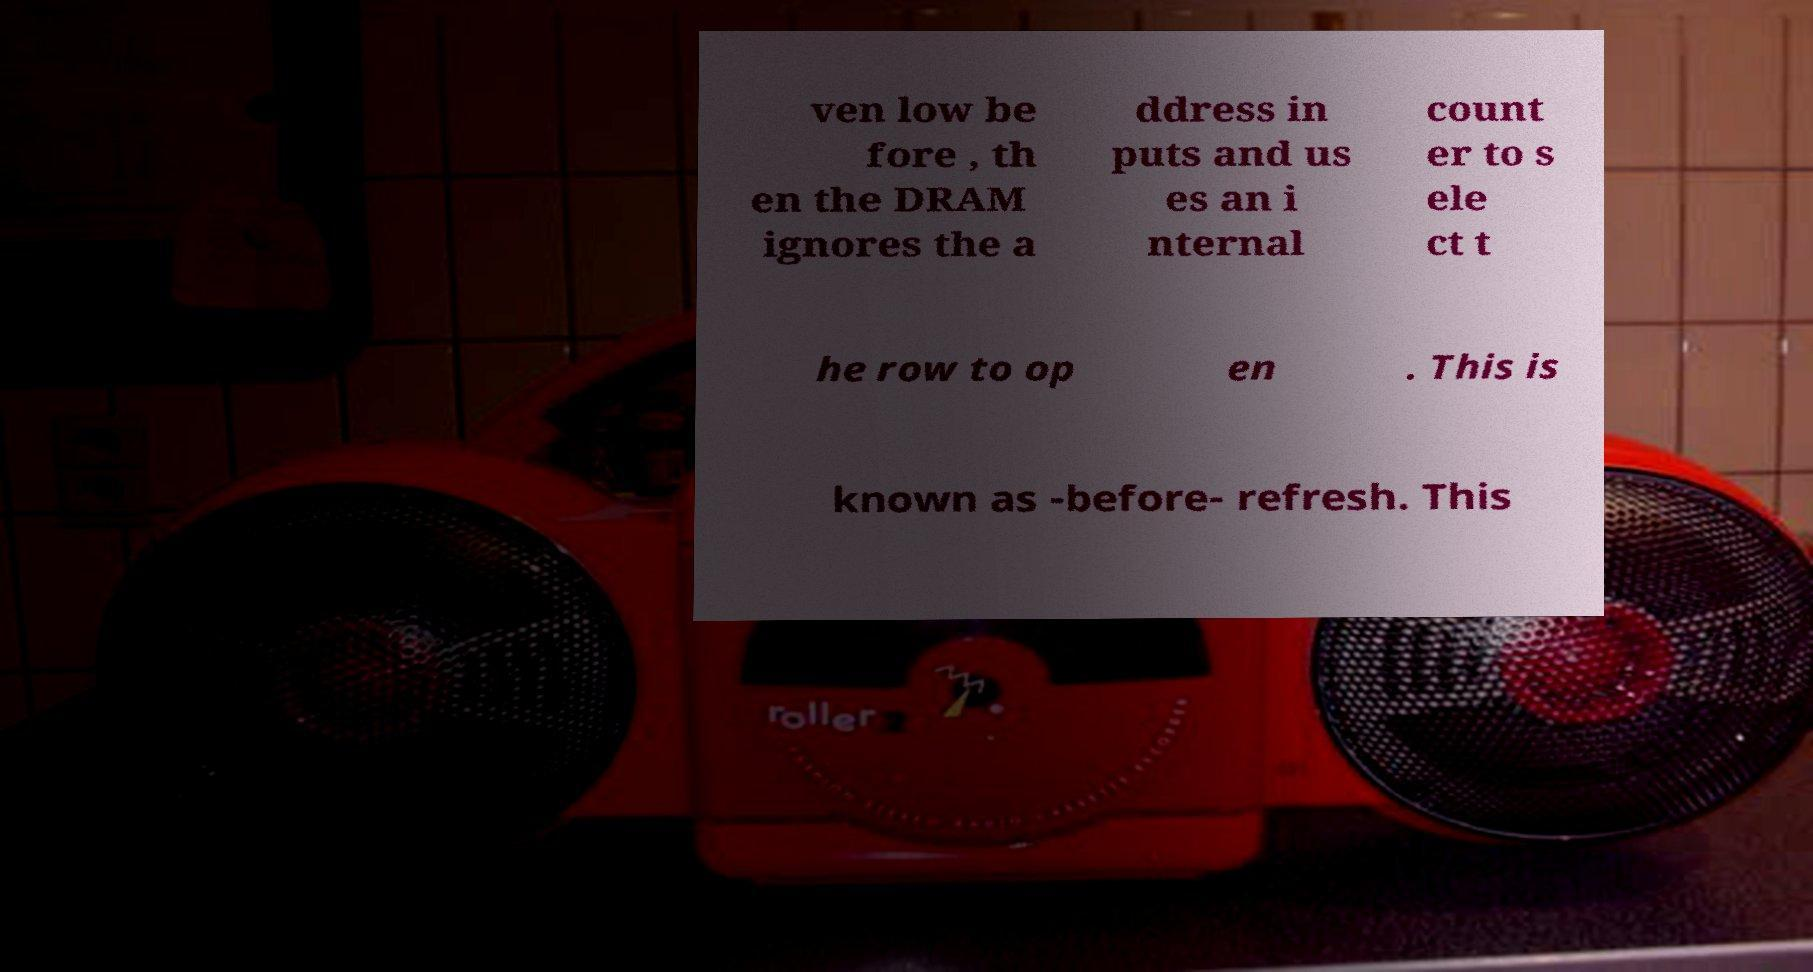What messages or text are displayed in this image? I need them in a readable, typed format. ven low be fore , th en the DRAM ignores the a ddress in puts and us es an i nternal count er to s ele ct t he row to op en . This is known as -before- refresh. This 